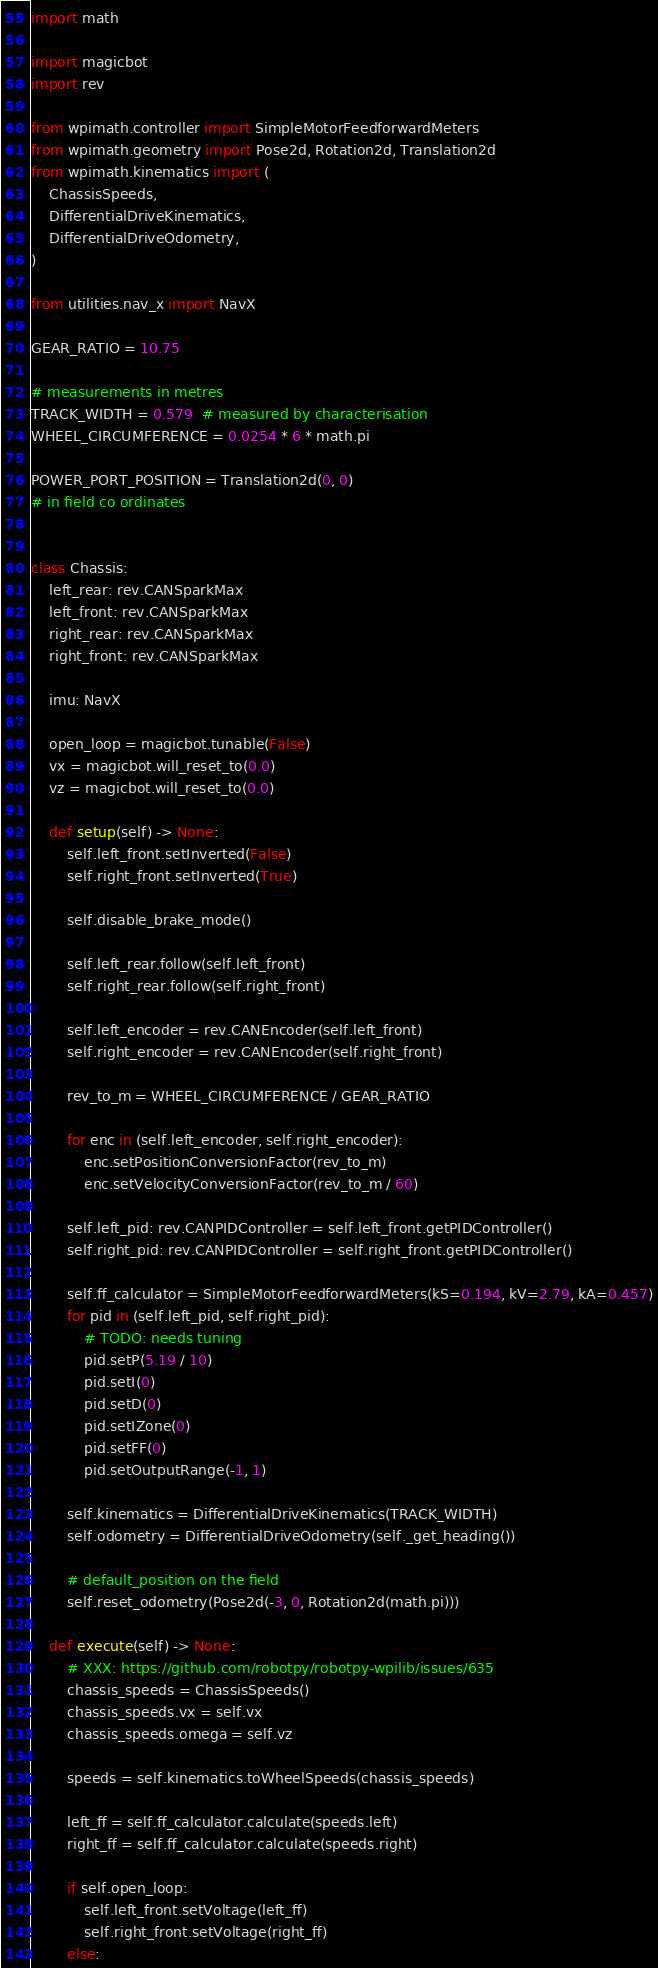<code> <loc_0><loc_0><loc_500><loc_500><_Python_>import math

import magicbot
import rev

from wpimath.controller import SimpleMotorFeedforwardMeters
from wpimath.geometry import Pose2d, Rotation2d, Translation2d
from wpimath.kinematics import (
    ChassisSpeeds,
    DifferentialDriveKinematics,
    DifferentialDriveOdometry,
)

from utilities.nav_x import NavX

GEAR_RATIO = 10.75

# measurements in metres
TRACK_WIDTH = 0.579  # measured by characterisation
WHEEL_CIRCUMFERENCE = 0.0254 * 6 * math.pi

POWER_PORT_POSITION = Translation2d(0, 0)
# in field co ordinates


class Chassis:
    left_rear: rev.CANSparkMax
    left_front: rev.CANSparkMax
    right_rear: rev.CANSparkMax
    right_front: rev.CANSparkMax

    imu: NavX

    open_loop = magicbot.tunable(False)
    vx = magicbot.will_reset_to(0.0)
    vz = magicbot.will_reset_to(0.0)

    def setup(self) -> None:
        self.left_front.setInverted(False)
        self.right_front.setInverted(True)

        self.disable_brake_mode()

        self.left_rear.follow(self.left_front)
        self.right_rear.follow(self.right_front)

        self.left_encoder = rev.CANEncoder(self.left_front)
        self.right_encoder = rev.CANEncoder(self.right_front)

        rev_to_m = WHEEL_CIRCUMFERENCE / GEAR_RATIO

        for enc in (self.left_encoder, self.right_encoder):
            enc.setPositionConversionFactor(rev_to_m)
            enc.setVelocityConversionFactor(rev_to_m / 60)

        self.left_pid: rev.CANPIDController = self.left_front.getPIDController()
        self.right_pid: rev.CANPIDController = self.right_front.getPIDController()

        self.ff_calculator = SimpleMotorFeedforwardMeters(kS=0.194, kV=2.79, kA=0.457)
        for pid in (self.left_pid, self.right_pid):
            # TODO: needs tuning
            pid.setP(5.19 / 10)
            pid.setI(0)
            pid.setD(0)
            pid.setIZone(0)
            pid.setFF(0)
            pid.setOutputRange(-1, 1)

        self.kinematics = DifferentialDriveKinematics(TRACK_WIDTH)
        self.odometry = DifferentialDriveOdometry(self._get_heading())

        # default_position on the field
        self.reset_odometry(Pose2d(-3, 0, Rotation2d(math.pi)))

    def execute(self) -> None:
        # XXX: https://github.com/robotpy/robotpy-wpilib/issues/635
        chassis_speeds = ChassisSpeeds()
        chassis_speeds.vx = self.vx
        chassis_speeds.omega = self.vz

        speeds = self.kinematics.toWheelSpeeds(chassis_speeds)

        left_ff = self.ff_calculator.calculate(speeds.left)
        right_ff = self.ff_calculator.calculate(speeds.right)

        if self.open_loop:
            self.left_front.setVoltage(left_ff)
            self.right_front.setVoltage(right_ff)
        else:</code> 